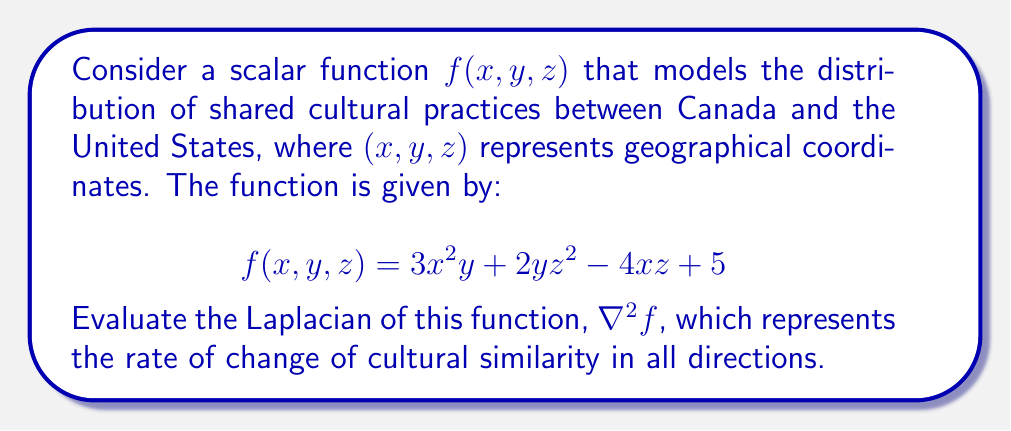Teach me how to tackle this problem. To evaluate the Laplacian of the scalar function $f(x,y,z)$, we need to follow these steps:

1) The Laplacian of a scalar function in 3D Cartesian coordinates is defined as:

   $$\nabla^2f = \frac{\partial^2f}{\partial x^2} + \frac{\partial^2f}{\partial y^2} + \frac{\partial^2f}{\partial z^2}$$

2) Let's calculate each second partial derivative:

   a) $\frac{\partial^2f}{\partial x^2}$:
      First, $\frac{\partial f}{\partial x} = 6xy - 4z$
      Then, $\frac{\partial^2f}{\partial x^2} = 6y$

   b) $\frac{\partial^2f}{\partial y^2}$:
      First, $\frac{\partial f}{\partial y} = 3x^2 + 2z^2$
      Then, $\frac{\partial^2f}{\partial y^2} = 0$

   c) $\frac{\partial^2f}{\partial z^2}$:
      First, $\frac{\partial f}{\partial z} = 4yz - 4x$
      Then, $\frac{\partial^2f}{\partial z^2} = 4y$

3) Now, we sum these second partial derivatives:

   $$\nabla^2f = \frac{\partial^2f}{\partial x^2} + \frac{\partial^2f}{\partial y^2} + \frac{\partial^2f}{\partial z^2}$$
   $$\nabla^2f = 6y + 0 + 4y$$
   $$\nabla^2f = 10y$$

This result indicates that the rate of change of cultural similarity is linearly dependent on the y-coordinate, which could represent the north-south axis between Canada and the United States.
Answer: $\nabla^2f = 10y$ 